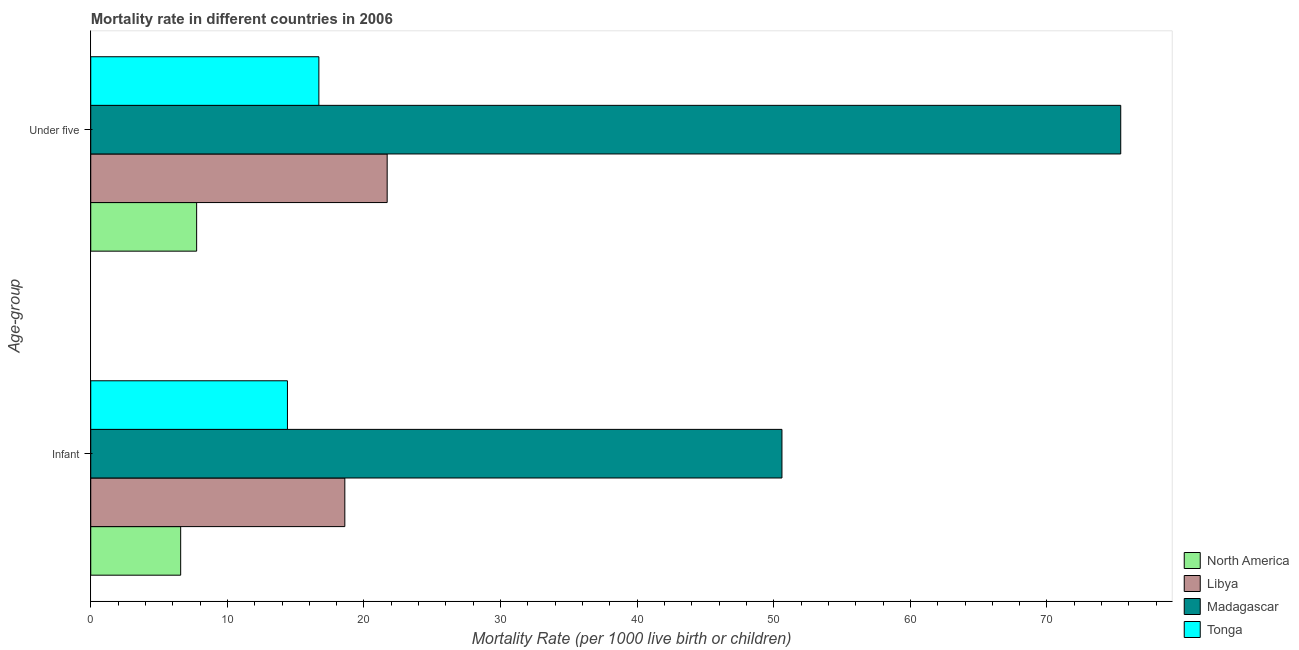How many different coloured bars are there?
Your answer should be compact. 4. How many bars are there on the 1st tick from the top?
Your answer should be compact. 4. What is the label of the 1st group of bars from the top?
Ensure brevity in your answer.  Under five. What is the under-5 mortality rate in North America?
Offer a terse response. 7.75. Across all countries, what is the maximum infant mortality rate?
Keep it short and to the point. 50.6. Across all countries, what is the minimum under-5 mortality rate?
Keep it short and to the point. 7.75. In which country was the infant mortality rate maximum?
Make the answer very short. Madagascar. In which country was the infant mortality rate minimum?
Your answer should be very brief. North America. What is the total under-5 mortality rate in the graph?
Your response must be concise. 121.55. What is the difference between the under-5 mortality rate in Libya and that in Madagascar?
Your answer should be very brief. -53.7. What is the difference between the infant mortality rate in Madagascar and the under-5 mortality rate in Tonga?
Make the answer very short. 33.9. What is the average under-5 mortality rate per country?
Make the answer very short. 30.39. What is the difference between the under-5 mortality rate and infant mortality rate in Tonga?
Offer a very short reply. 2.3. What is the ratio of the under-5 mortality rate in Tonga to that in North America?
Your response must be concise. 2.15. Is the under-5 mortality rate in North America less than that in Tonga?
Ensure brevity in your answer.  Yes. In how many countries, is the under-5 mortality rate greater than the average under-5 mortality rate taken over all countries?
Make the answer very short. 1. What does the 1st bar from the top in Under five represents?
Your response must be concise. Tonga. What does the 3rd bar from the bottom in Infant represents?
Your answer should be compact. Madagascar. How many bars are there?
Provide a succinct answer. 8. How many countries are there in the graph?
Provide a short and direct response. 4. What is the difference between two consecutive major ticks on the X-axis?
Provide a short and direct response. 10. Does the graph contain grids?
Ensure brevity in your answer.  No. Where does the legend appear in the graph?
Offer a terse response. Bottom right. What is the title of the graph?
Your answer should be compact. Mortality rate in different countries in 2006. What is the label or title of the X-axis?
Your answer should be compact. Mortality Rate (per 1000 live birth or children). What is the label or title of the Y-axis?
Your answer should be very brief. Age-group. What is the Mortality Rate (per 1000 live birth or children) in North America in Infant?
Your answer should be very brief. 6.58. What is the Mortality Rate (per 1000 live birth or children) of Madagascar in Infant?
Ensure brevity in your answer.  50.6. What is the Mortality Rate (per 1000 live birth or children) of Tonga in Infant?
Your response must be concise. 14.4. What is the Mortality Rate (per 1000 live birth or children) of North America in Under five?
Provide a short and direct response. 7.75. What is the Mortality Rate (per 1000 live birth or children) in Libya in Under five?
Offer a terse response. 21.7. What is the Mortality Rate (per 1000 live birth or children) of Madagascar in Under five?
Your answer should be very brief. 75.4. Across all Age-group, what is the maximum Mortality Rate (per 1000 live birth or children) of North America?
Offer a very short reply. 7.75. Across all Age-group, what is the maximum Mortality Rate (per 1000 live birth or children) of Libya?
Give a very brief answer. 21.7. Across all Age-group, what is the maximum Mortality Rate (per 1000 live birth or children) in Madagascar?
Keep it short and to the point. 75.4. Across all Age-group, what is the maximum Mortality Rate (per 1000 live birth or children) in Tonga?
Offer a very short reply. 16.7. Across all Age-group, what is the minimum Mortality Rate (per 1000 live birth or children) in North America?
Offer a terse response. 6.58. Across all Age-group, what is the minimum Mortality Rate (per 1000 live birth or children) of Libya?
Offer a terse response. 18.6. Across all Age-group, what is the minimum Mortality Rate (per 1000 live birth or children) in Madagascar?
Provide a succinct answer. 50.6. What is the total Mortality Rate (per 1000 live birth or children) in North America in the graph?
Your answer should be very brief. 14.33. What is the total Mortality Rate (per 1000 live birth or children) in Libya in the graph?
Make the answer very short. 40.3. What is the total Mortality Rate (per 1000 live birth or children) of Madagascar in the graph?
Offer a terse response. 126. What is the total Mortality Rate (per 1000 live birth or children) in Tonga in the graph?
Ensure brevity in your answer.  31.1. What is the difference between the Mortality Rate (per 1000 live birth or children) in North America in Infant and that in Under five?
Keep it short and to the point. -1.17. What is the difference between the Mortality Rate (per 1000 live birth or children) of Madagascar in Infant and that in Under five?
Offer a terse response. -24.8. What is the difference between the Mortality Rate (per 1000 live birth or children) in North America in Infant and the Mortality Rate (per 1000 live birth or children) in Libya in Under five?
Offer a terse response. -15.12. What is the difference between the Mortality Rate (per 1000 live birth or children) in North America in Infant and the Mortality Rate (per 1000 live birth or children) in Madagascar in Under five?
Make the answer very short. -68.82. What is the difference between the Mortality Rate (per 1000 live birth or children) in North America in Infant and the Mortality Rate (per 1000 live birth or children) in Tonga in Under five?
Provide a succinct answer. -10.12. What is the difference between the Mortality Rate (per 1000 live birth or children) in Libya in Infant and the Mortality Rate (per 1000 live birth or children) in Madagascar in Under five?
Provide a succinct answer. -56.8. What is the difference between the Mortality Rate (per 1000 live birth or children) of Libya in Infant and the Mortality Rate (per 1000 live birth or children) of Tonga in Under five?
Your response must be concise. 1.9. What is the difference between the Mortality Rate (per 1000 live birth or children) of Madagascar in Infant and the Mortality Rate (per 1000 live birth or children) of Tonga in Under five?
Your answer should be very brief. 33.9. What is the average Mortality Rate (per 1000 live birth or children) in North America per Age-group?
Offer a very short reply. 7.17. What is the average Mortality Rate (per 1000 live birth or children) in Libya per Age-group?
Your answer should be very brief. 20.15. What is the average Mortality Rate (per 1000 live birth or children) of Madagascar per Age-group?
Give a very brief answer. 63. What is the average Mortality Rate (per 1000 live birth or children) of Tonga per Age-group?
Your answer should be very brief. 15.55. What is the difference between the Mortality Rate (per 1000 live birth or children) of North America and Mortality Rate (per 1000 live birth or children) of Libya in Infant?
Give a very brief answer. -12.02. What is the difference between the Mortality Rate (per 1000 live birth or children) of North America and Mortality Rate (per 1000 live birth or children) of Madagascar in Infant?
Your response must be concise. -44.02. What is the difference between the Mortality Rate (per 1000 live birth or children) of North America and Mortality Rate (per 1000 live birth or children) of Tonga in Infant?
Keep it short and to the point. -7.82. What is the difference between the Mortality Rate (per 1000 live birth or children) in Libya and Mortality Rate (per 1000 live birth or children) in Madagascar in Infant?
Your response must be concise. -32. What is the difference between the Mortality Rate (per 1000 live birth or children) of Libya and Mortality Rate (per 1000 live birth or children) of Tonga in Infant?
Provide a short and direct response. 4.2. What is the difference between the Mortality Rate (per 1000 live birth or children) in Madagascar and Mortality Rate (per 1000 live birth or children) in Tonga in Infant?
Your response must be concise. 36.2. What is the difference between the Mortality Rate (per 1000 live birth or children) in North America and Mortality Rate (per 1000 live birth or children) in Libya in Under five?
Ensure brevity in your answer.  -13.95. What is the difference between the Mortality Rate (per 1000 live birth or children) in North America and Mortality Rate (per 1000 live birth or children) in Madagascar in Under five?
Offer a terse response. -67.65. What is the difference between the Mortality Rate (per 1000 live birth or children) of North America and Mortality Rate (per 1000 live birth or children) of Tonga in Under five?
Offer a very short reply. -8.95. What is the difference between the Mortality Rate (per 1000 live birth or children) in Libya and Mortality Rate (per 1000 live birth or children) in Madagascar in Under five?
Your response must be concise. -53.7. What is the difference between the Mortality Rate (per 1000 live birth or children) of Madagascar and Mortality Rate (per 1000 live birth or children) of Tonga in Under five?
Make the answer very short. 58.7. What is the ratio of the Mortality Rate (per 1000 live birth or children) in North America in Infant to that in Under five?
Offer a very short reply. 0.85. What is the ratio of the Mortality Rate (per 1000 live birth or children) in Libya in Infant to that in Under five?
Make the answer very short. 0.86. What is the ratio of the Mortality Rate (per 1000 live birth or children) in Madagascar in Infant to that in Under five?
Ensure brevity in your answer.  0.67. What is the ratio of the Mortality Rate (per 1000 live birth or children) of Tonga in Infant to that in Under five?
Offer a very short reply. 0.86. What is the difference between the highest and the second highest Mortality Rate (per 1000 live birth or children) of North America?
Give a very brief answer. 1.17. What is the difference between the highest and the second highest Mortality Rate (per 1000 live birth or children) of Libya?
Provide a succinct answer. 3.1. What is the difference between the highest and the second highest Mortality Rate (per 1000 live birth or children) in Madagascar?
Make the answer very short. 24.8. What is the difference between the highest and the second highest Mortality Rate (per 1000 live birth or children) in Tonga?
Provide a succinct answer. 2.3. What is the difference between the highest and the lowest Mortality Rate (per 1000 live birth or children) in North America?
Keep it short and to the point. 1.17. What is the difference between the highest and the lowest Mortality Rate (per 1000 live birth or children) in Libya?
Keep it short and to the point. 3.1. What is the difference between the highest and the lowest Mortality Rate (per 1000 live birth or children) of Madagascar?
Your answer should be compact. 24.8. 